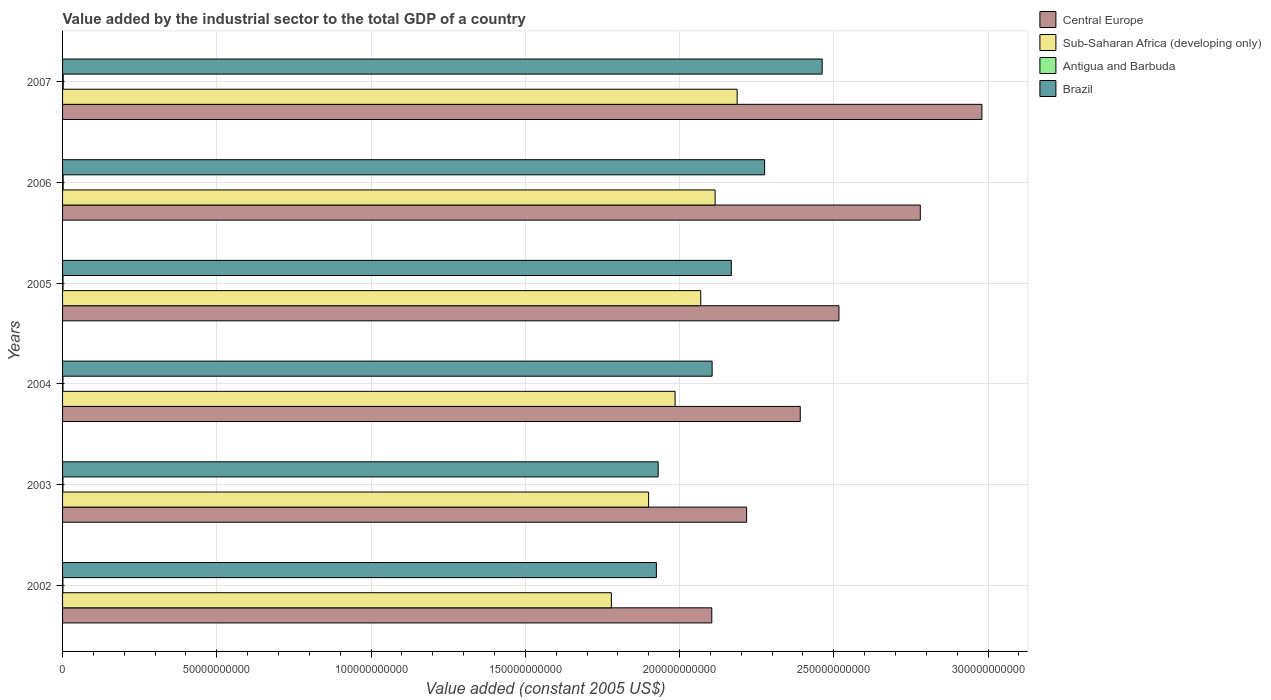How many different coloured bars are there?
Ensure brevity in your answer.  4. How many bars are there on the 5th tick from the bottom?
Keep it short and to the point. 4. What is the label of the 3rd group of bars from the top?
Keep it short and to the point. 2005. What is the value added by the industrial sector in Antigua and Barbuda in 2005?
Ensure brevity in your answer.  1.49e+08. Across all years, what is the maximum value added by the industrial sector in Brazil?
Your answer should be compact. 2.46e+11. Across all years, what is the minimum value added by the industrial sector in Sub-Saharan Africa (developing only)?
Your answer should be very brief. 1.78e+11. In which year was the value added by the industrial sector in Brazil minimum?
Make the answer very short. 2002. What is the total value added by the industrial sector in Antigua and Barbuda in the graph?
Offer a very short reply. 9.26e+08. What is the difference between the value added by the industrial sector in Central Europe in 2003 and that in 2006?
Your answer should be compact. -5.63e+1. What is the difference between the value added by the industrial sector in Brazil in 2006 and the value added by the industrial sector in Antigua and Barbuda in 2003?
Your answer should be compact. 2.27e+11. What is the average value added by the industrial sector in Sub-Saharan Africa (developing only) per year?
Provide a succinct answer. 2.01e+11. In the year 2004, what is the difference between the value added by the industrial sector in Brazil and value added by the industrial sector in Antigua and Barbuda?
Ensure brevity in your answer.  2.10e+11. In how many years, is the value added by the industrial sector in Antigua and Barbuda greater than 10000000000 US$?
Your answer should be very brief. 0. What is the ratio of the value added by the industrial sector in Sub-Saharan Africa (developing only) in 2002 to that in 2005?
Your response must be concise. 0.86. Is the value added by the industrial sector in Sub-Saharan Africa (developing only) in 2003 less than that in 2007?
Ensure brevity in your answer.  Yes. What is the difference between the highest and the second highest value added by the industrial sector in Brazil?
Keep it short and to the point. 1.87e+1. What is the difference between the highest and the lowest value added by the industrial sector in Central Europe?
Give a very brief answer. 8.76e+1. Is it the case that in every year, the sum of the value added by the industrial sector in Antigua and Barbuda and value added by the industrial sector in Sub-Saharan Africa (developing only) is greater than the sum of value added by the industrial sector in Central Europe and value added by the industrial sector in Brazil?
Provide a short and direct response. Yes. What does the 3rd bar from the top in 2006 represents?
Ensure brevity in your answer.  Sub-Saharan Africa (developing only). What does the 2nd bar from the bottom in 2006 represents?
Ensure brevity in your answer.  Sub-Saharan Africa (developing only). Is it the case that in every year, the sum of the value added by the industrial sector in Antigua and Barbuda and value added by the industrial sector in Sub-Saharan Africa (developing only) is greater than the value added by the industrial sector in Brazil?
Your answer should be very brief. No. Are all the bars in the graph horizontal?
Keep it short and to the point. Yes. Are the values on the major ticks of X-axis written in scientific E-notation?
Make the answer very short. No. Where does the legend appear in the graph?
Make the answer very short. Top right. How many legend labels are there?
Your answer should be very brief. 4. How are the legend labels stacked?
Offer a very short reply. Vertical. What is the title of the graph?
Offer a very short reply. Value added by the industrial sector to the total GDP of a country. Does "Lower middle income" appear as one of the legend labels in the graph?
Ensure brevity in your answer.  No. What is the label or title of the X-axis?
Keep it short and to the point. Value added (constant 2005 US$). What is the label or title of the Y-axis?
Make the answer very short. Years. What is the Value added (constant 2005 US$) of Central Europe in 2002?
Keep it short and to the point. 2.10e+11. What is the Value added (constant 2005 US$) in Sub-Saharan Africa (developing only) in 2002?
Provide a succinct answer. 1.78e+11. What is the Value added (constant 2005 US$) of Antigua and Barbuda in 2002?
Keep it short and to the point. 1.12e+08. What is the Value added (constant 2005 US$) in Brazil in 2002?
Provide a succinct answer. 1.92e+11. What is the Value added (constant 2005 US$) of Central Europe in 2003?
Keep it short and to the point. 2.22e+11. What is the Value added (constant 2005 US$) in Sub-Saharan Africa (developing only) in 2003?
Your response must be concise. 1.90e+11. What is the Value added (constant 2005 US$) in Antigua and Barbuda in 2003?
Make the answer very short. 1.22e+08. What is the Value added (constant 2005 US$) of Brazil in 2003?
Keep it short and to the point. 1.93e+11. What is the Value added (constant 2005 US$) of Central Europe in 2004?
Your response must be concise. 2.39e+11. What is the Value added (constant 2005 US$) in Sub-Saharan Africa (developing only) in 2004?
Offer a very short reply. 1.99e+11. What is the Value added (constant 2005 US$) of Antigua and Barbuda in 2004?
Your answer should be compact. 1.24e+08. What is the Value added (constant 2005 US$) of Brazil in 2004?
Your response must be concise. 2.11e+11. What is the Value added (constant 2005 US$) of Central Europe in 2005?
Ensure brevity in your answer.  2.52e+11. What is the Value added (constant 2005 US$) in Sub-Saharan Africa (developing only) in 2005?
Keep it short and to the point. 2.07e+11. What is the Value added (constant 2005 US$) of Antigua and Barbuda in 2005?
Make the answer very short. 1.49e+08. What is the Value added (constant 2005 US$) in Brazil in 2005?
Make the answer very short. 2.17e+11. What is the Value added (constant 2005 US$) in Central Europe in 2006?
Your response must be concise. 2.78e+11. What is the Value added (constant 2005 US$) in Sub-Saharan Africa (developing only) in 2006?
Make the answer very short. 2.12e+11. What is the Value added (constant 2005 US$) of Antigua and Barbuda in 2006?
Offer a terse response. 2.01e+08. What is the Value added (constant 2005 US$) in Brazil in 2006?
Ensure brevity in your answer.  2.28e+11. What is the Value added (constant 2005 US$) of Central Europe in 2007?
Keep it short and to the point. 2.98e+11. What is the Value added (constant 2005 US$) in Sub-Saharan Africa (developing only) in 2007?
Offer a very short reply. 2.19e+11. What is the Value added (constant 2005 US$) of Antigua and Barbuda in 2007?
Your answer should be very brief. 2.17e+08. What is the Value added (constant 2005 US$) in Brazil in 2007?
Offer a very short reply. 2.46e+11. Across all years, what is the maximum Value added (constant 2005 US$) in Central Europe?
Ensure brevity in your answer.  2.98e+11. Across all years, what is the maximum Value added (constant 2005 US$) in Sub-Saharan Africa (developing only)?
Your answer should be very brief. 2.19e+11. Across all years, what is the maximum Value added (constant 2005 US$) in Antigua and Barbuda?
Offer a very short reply. 2.17e+08. Across all years, what is the maximum Value added (constant 2005 US$) of Brazil?
Ensure brevity in your answer.  2.46e+11. Across all years, what is the minimum Value added (constant 2005 US$) in Central Europe?
Provide a succinct answer. 2.10e+11. Across all years, what is the minimum Value added (constant 2005 US$) in Sub-Saharan Africa (developing only)?
Make the answer very short. 1.78e+11. Across all years, what is the minimum Value added (constant 2005 US$) in Antigua and Barbuda?
Make the answer very short. 1.12e+08. Across all years, what is the minimum Value added (constant 2005 US$) in Brazil?
Give a very brief answer. 1.92e+11. What is the total Value added (constant 2005 US$) in Central Europe in the graph?
Offer a terse response. 1.50e+12. What is the total Value added (constant 2005 US$) in Sub-Saharan Africa (developing only) in the graph?
Your answer should be very brief. 1.20e+12. What is the total Value added (constant 2005 US$) of Antigua and Barbuda in the graph?
Offer a terse response. 9.26e+08. What is the total Value added (constant 2005 US$) of Brazil in the graph?
Offer a very short reply. 1.29e+12. What is the difference between the Value added (constant 2005 US$) of Central Europe in 2002 and that in 2003?
Keep it short and to the point. -1.13e+1. What is the difference between the Value added (constant 2005 US$) in Sub-Saharan Africa (developing only) in 2002 and that in 2003?
Give a very brief answer. -1.21e+1. What is the difference between the Value added (constant 2005 US$) in Antigua and Barbuda in 2002 and that in 2003?
Make the answer very short. -9.71e+06. What is the difference between the Value added (constant 2005 US$) in Brazil in 2002 and that in 2003?
Your answer should be very brief. -5.84e+08. What is the difference between the Value added (constant 2005 US$) of Central Europe in 2002 and that in 2004?
Offer a terse response. -2.87e+1. What is the difference between the Value added (constant 2005 US$) of Sub-Saharan Africa (developing only) in 2002 and that in 2004?
Give a very brief answer. -2.07e+1. What is the difference between the Value added (constant 2005 US$) of Antigua and Barbuda in 2002 and that in 2004?
Ensure brevity in your answer.  -1.19e+07. What is the difference between the Value added (constant 2005 US$) of Brazil in 2002 and that in 2004?
Offer a terse response. -1.81e+1. What is the difference between the Value added (constant 2005 US$) in Central Europe in 2002 and that in 2005?
Make the answer very short. -4.12e+1. What is the difference between the Value added (constant 2005 US$) of Sub-Saharan Africa (developing only) in 2002 and that in 2005?
Provide a short and direct response. -2.90e+1. What is the difference between the Value added (constant 2005 US$) in Antigua and Barbuda in 2002 and that in 2005?
Provide a succinct answer. -3.62e+07. What is the difference between the Value added (constant 2005 US$) in Brazil in 2002 and that in 2005?
Ensure brevity in your answer.  -2.43e+1. What is the difference between the Value added (constant 2005 US$) in Central Europe in 2002 and that in 2006?
Offer a very short reply. -6.76e+1. What is the difference between the Value added (constant 2005 US$) of Sub-Saharan Africa (developing only) in 2002 and that in 2006?
Offer a terse response. -3.36e+1. What is the difference between the Value added (constant 2005 US$) in Antigua and Barbuda in 2002 and that in 2006?
Your answer should be compact. -8.89e+07. What is the difference between the Value added (constant 2005 US$) in Brazil in 2002 and that in 2006?
Offer a terse response. -3.51e+1. What is the difference between the Value added (constant 2005 US$) in Central Europe in 2002 and that in 2007?
Make the answer very short. -8.76e+1. What is the difference between the Value added (constant 2005 US$) in Sub-Saharan Africa (developing only) in 2002 and that in 2007?
Provide a succinct answer. -4.08e+1. What is the difference between the Value added (constant 2005 US$) in Antigua and Barbuda in 2002 and that in 2007?
Provide a short and direct response. -1.05e+08. What is the difference between the Value added (constant 2005 US$) in Brazil in 2002 and that in 2007?
Make the answer very short. -5.37e+1. What is the difference between the Value added (constant 2005 US$) of Central Europe in 2003 and that in 2004?
Offer a terse response. -1.74e+1. What is the difference between the Value added (constant 2005 US$) of Sub-Saharan Africa (developing only) in 2003 and that in 2004?
Your response must be concise. -8.58e+09. What is the difference between the Value added (constant 2005 US$) in Antigua and Barbuda in 2003 and that in 2004?
Your answer should be compact. -2.22e+06. What is the difference between the Value added (constant 2005 US$) in Brazil in 2003 and that in 2004?
Provide a succinct answer. -1.75e+1. What is the difference between the Value added (constant 2005 US$) in Central Europe in 2003 and that in 2005?
Make the answer very short. -2.99e+1. What is the difference between the Value added (constant 2005 US$) of Sub-Saharan Africa (developing only) in 2003 and that in 2005?
Your answer should be compact. -1.69e+1. What is the difference between the Value added (constant 2005 US$) of Antigua and Barbuda in 2003 and that in 2005?
Provide a succinct answer. -2.65e+07. What is the difference between the Value added (constant 2005 US$) in Brazil in 2003 and that in 2005?
Your answer should be compact. -2.37e+1. What is the difference between the Value added (constant 2005 US$) of Central Europe in 2003 and that in 2006?
Your response must be concise. -5.63e+1. What is the difference between the Value added (constant 2005 US$) of Sub-Saharan Africa (developing only) in 2003 and that in 2006?
Provide a short and direct response. -2.16e+1. What is the difference between the Value added (constant 2005 US$) of Antigua and Barbuda in 2003 and that in 2006?
Give a very brief answer. -7.92e+07. What is the difference between the Value added (constant 2005 US$) of Brazil in 2003 and that in 2006?
Your response must be concise. -3.45e+1. What is the difference between the Value added (constant 2005 US$) of Central Europe in 2003 and that in 2007?
Keep it short and to the point. -7.63e+1. What is the difference between the Value added (constant 2005 US$) in Sub-Saharan Africa (developing only) in 2003 and that in 2007?
Offer a terse response. -2.87e+1. What is the difference between the Value added (constant 2005 US$) of Antigua and Barbuda in 2003 and that in 2007?
Provide a short and direct response. -9.55e+07. What is the difference between the Value added (constant 2005 US$) in Brazil in 2003 and that in 2007?
Ensure brevity in your answer.  -5.32e+1. What is the difference between the Value added (constant 2005 US$) in Central Europe in 2004 and that in 2005?
Your answer should be very brief. -1.25e+1. What is the difference between the Value added (constant 2005 US$) in Sub-Saharan Africa (developing only) in 2004 and that in 2005?
Offer a very short reply. -8.32e+09. What is the difference between the Value added (constant 2005 US$) in Antigua and Barbuda in 2004 and that in 2005?
Ensure brevity in your answer.  -2.43e+07. What is the difference between the Value added (constant 2005 US$) of Brazil in 2004 and that in 2005?
Make the answer very short. -6.22e+09. What is the difference between the Value added (constant 2005 US$) in Central Europe in 2004 and that in 2006?
Your answer should be very brief. -3.89e+1. What is the difference between the Value added (constant 2005 US$) in Sub-Saharan Africa (developing only) in 2004 and that in 2006?
Offer a very short reply. -1.30e+1. What is the difference between the Value added (constant 2005 US$) of Antigua and Barbuda in 2004 and that in 2006?
Give a very brief answer. -7.69e+07. What is the difference between the Value added (constant 2005 US$) of Brazil in 2004 and that in 2006?
Offer a terse response. -1.70e+1. What is the difference between the Value added (constant 2005 US$) of Central Europe in 2004 and that in 2007?
Ensure brevity in your answer.  -5.89e+1. What is the difference between the Value added (constant 2005 US$) of Sub-Saharan Africa (developing only) in 2004 and that in 2007?
Keep it short and to the point. -2.01e+1. What is the difference between the Value added (constant 2005 US$) in Antigua and Barbuda in 2004 and that in 2007?
Provide a short and direct response. -9.32e+07. What is the difference between the Value added (constant 2005 US$) in Brazil in 2004 and that in 2007?
Offer a terse response. -3.57e+1. What is the difference between the Value added (constant 2005 US$) in Central Europe in 2005 and that in 2006?
Ensure brevity in your answer.  -2.64e+1. What is the difference between the Value added (constant 2005 US$) of Sub-Saharan Africa (developing only) in 2005 and that in 2006?
Your answer should be compact. -4.66e+09. What is the difference between the Value added (constant 2005 US$) in Antigua and Barbuda in 2005 and that in 2006?
Make the answer very short. -5.26e+07. What is the difference between the Value added (constant 2005 US$) of Brazil in 2005 and that in 2006?
Your response must be concise. -1.08e+1. What is the difference between the Value added (constant 2005 US$) of Central Europe in 2005 and that in 2007?
Ensure brevity in your answer.  -4.63e+1. What is the difference between the Value added (constant 2005 US$) of Sub-Saharan Africa (developing only) in 2005 and that in 2007?
Provide a succinct answer. -1.18e+1. What is the difference between the Value added (constant 2005 US$) of Antigua and Barbuda in 2005 and that in 2007?
Give a very brief answer. -6.89e+07. What is the difference between the Value added (constant 2005 US$) of Brazil in 2005 and that in 2007?
Make the answer very short. -2.95e+1. What is the difference between the Value added (constant 2005 US$) in Central Europe in 2006 and that in 2007?
Give a very brief answer. -2.00e+1. What is the difference between the Value added (constant 2005 US$) of Sub-Saharan Africa (developing only) in 2006 and that in 2007?
Give a very brief answer. -7.14e+09. What is the difference between the Value added (constant 2005 US$) of Antigua and Barbuda in 2006 and that in 2007?
Your answer should be compact. -1.63e+07. What is the difference between the Value added (constant 2005 US$) in Brazil in 2006 and that in 2007?
Ensure brevity in your answer.  -1.87e+1. What is the difference between the Value added (constant 2005 US$) of Central Europe in 2002 and the Value added (constant 2005 US$) of Sub-Saharan Africa (developing only) in 2003?
Ensure brevity in your answer.  2.05e+1. What is the difference between the Value added (constant 2005 US$) in Central Europe in 2002 and the Value added (constant 2005 US$) in Antigua and Barbuda in 2003?
Offer a terse response. 2.10e+11. What is the difference between the Value added (constant 2005 US$) in Central Europe in 2002 and the Value added (constant 2005 US$) in Brazil in 2003?
Provide a succinct answer. 1.74e+1. What is the difference between the Value added (constant 2005 US$) in Sub-Saharan Africa (developing only) in 2002 and the Value added (constant 2005 US$) in Antigua and Barbuda in 2003?
Keep it short and to the point. 1.78e+11. What is the difference between the Value added (constant 2005 US$) in Sub-Saharan Africa (developing only) in 2002 and the Value added (constant 2005 US$) in Brazil in 2003?
Provide a short and direct response. -1.52e+1. What is the difference between the Value added (constant 2005 US$) in Antigua and Barbuda in 2002 and the Value added (constant 2005 US$) in Brazil in 2003?
Provide a short and direct response. -1.93e+11. What is the difference between the Value added (constant 2005 US$) of Central Europe in 2002 and the Value added (constant 2005 US$) of Sub-Saharan Africa (developing only) in 2004?
Provide a short and direct response. 1.19e+1. What is the difference between the Value added (constant 2005 US$) in Central Europe in 2002 and the Value added (constant 2005 US$) in Antigua and Barbuda in 2004?
Your answer should be compact. 2.10e+11. What is the difference between the Value added (constant 2005 US$) of Central Europe in 2002 and the Value added (constant 2005 US$) of Brazil in 2004?
Your answer should be very brief. -1.05e+08. What is the difference between the Value added (constant 2005 US$) in Sub-Saharan Africa (developing only) in 2002 and the Value added (constant 2005 US$) in Antigua and Barbuda in 2004?
Offer a terse response. 1.78e+11. What is the difference between the Value added (constant 2005 US$) of Sub-Saharan Africa (developing only) in 2002 and the Value added (constant 2005 US$) of Brazil in 2004?
Give a very brief answer. -3.27e+1. What is the difference between the Value added (constant 2005 US$) of Antigua and Barbuda in 2002 and the Value added (constant 2005 US$) of Brazil in 2004?
Provide a succinct answer. -2.10e+11. What is the difference between the Value added (constant 2005 US$) in Central Europe in 2002 and the Value added (constant 2005 US$) in Sub-Saharan Africa (developing only) in 2005?
Your answer should be compact. 3.58e+09. What is the difference between the Value added (constant 2005 US$) of Central Europe in 2002 and the Value added (constant 2005 US$) of Antigua and Barbuda in 2005?
Offer a terse response. 2.10e+11. What is the difference between the Value added (constant 2005 US$) of Central Europe in 2002 and the Value added (constant 2005 US$) of Brazil in 2005?
Offer a very short reply. -6.33e+09. What is the difference between the Value added (constant 2005 US$) of Sub-Saharan Africa (developing only) in 2002 and the Value added (constant 2005 US$) of Antigua and Barbuda in 2005?
Keep it short and to the point. 1.78e+11. What is the difference between the Value added (constant 2005 US$) of Sub-Saharan Africa (developing only) in 2002 and the Value added (constant 2005 US$) of Brazil in 2005?
Provide a short and direct response. -3.89e+1. What is the difference between the Value added (constant 2005 US$) in Antigua and Barbuda in 2002 and the Value added (constant 2005 US$) in Brazil in 2005?
Your answer should be compact. -2.17e+11. What is the difference between the Value added (constant 2005 US$) in Central Europe in 2002 and the Value added (constant 2005 US$) in Sub-Saharan Africa (developing only) in 2006?
Make the answer very short. -1.07e+09. What is the difference between the Value added (constant 2005 US$) in Central Europe in 2002 and the Value added (constant 2005 US$) in Antigua and Barbuda in 2006?
Provide a succinct answer. 2.10e+11. What is the difference between the Value added (constant 2005 US$) of Central Europe in 2002 and the Value added (constant 2005 US$) of Brazil in 2006?
Offer a very short reply. -1.71e+1. What is the difference between the Value added (constant 2005 US$) in Sub-Saharan Africa (developing only) in 2002 and the Value added (constant 2005 US$) in Antigua and Barbuda in 2006?
Offer a terse response. 1.78e+11. What is the difference between the Value added (constant 2005 US$) in Sub-Saharan Africa (developing only) in 2002 and the Value added (constant 2005 US$) in Brazil in 2006?
Your answer should be very brief. -4.97e+1. What is the difference between the Value added (constant 2005 US$) of Antigua and Barbuda in 2002 and the Value added (constant 2005 US$) of Brazil in 2006?
Provide a short and direct response. -2.27e+11. What is the difference between the Value added (constant 2005 US$) in Central Europe in 2002 and the Value added (constant 2005 US$) in Sub-Saharan Africa (developing only) in 2007?
Make the answer very short. -8.21e+09. What is the difference between the Value added (constant 2005 US$) of Central Europe in 2002 and the Value added (constant 2005 US$) of Antigua and Barbuda in 2007?
Your answer should be very brief. 2.10e+11. What is the difference between the Value added (constant 2005 US$) in Central Europe in 2002 and the Value added (constant 2005 US$) in Brazil in 2007?
Offer a very short reply. -3.58e+1. What is the difference between the Value added (constant 2005 US$) of Sub-Saharan Africa (developing only) in 2002 and the Value added (constant 2005 US$) of Antigua and Barbuda in 2007?
Offer a very short reply. 1.78e+11. What is the difference between the Value added (constant 2005 US$) in Sub-Saharan Africa (developing only) in 2002 and the Value added (constant 2005 US$) in Brazil in 2007?
Provide a succinct answer. -6.83e+1. What is the difference between the Value added (constant 2005 US$) in Antigua and Barbuda in 2002 and the Value added (constant 2005 US$) in Brazil in 2007?
Your response must be concise. -2.46e+11. What is the difference between the Value added (constant 2005 US$) of Central Europe in 2003 and the Value added (constant 2005 US$) of Sub-Saharan Africa (developing only) in 2004?
Your response must be concise. 2.32e+1. What is the difference between the Value added (constant 2005 US$) of Central Europe in 2003 and the Value added (constant 2005 US$) of Antigua and Barbuda in 2004?
Offer a very short reply. 2.22e+11. What is the difference between the Value added (constant 2005 US$) in Central Europe in 2003 and the Value added (constant 2005 US$) in Brazil in 2004?
Your response must be concise. 1.12e+1. What is the difference between the Value added (constant 2005 US$) in Sub-Saharan Africa (developing only) in 2003 and the Value added (constant 2005 US$) in Antigua and Barbuda in 2004?
Ensure brevity in your answer.  1.90e+11. What is the difference between the Value added (constant 2005 US$) in Sub-Saharan Africa (developing only) in 2003 and the Value added (constant 2005 US$) in Brazil in 2004?
Give a very brief answer. -2.06e+1. What is the difference between the Value added (constant 2005 US$) in Antigua and Barbuda in 2003 and the Value added (constant 2005 US$) in Brazil in 2004?
Your answer should be compact. -2.10e+11. What is the difference between the Value added (constant 2005 US$) in Central Europe in 2003 and the Value added (constant 2005 US$) in Sub-Saharan Africa (developing only) in 2005?
Your answer should be very brief. 1.49e+1. What is the difference between the Value added (constant 2005 US$) of Central Europe in 2003 and the Value added (constant 2005 US$) of Antigua and Barbuda in 2005?
Offer a very short reply. 2.22e+11. What is the difference between the Value added (constant 2005 US$) of Central Europe in 2003 and the Value added (constant 2005 US$) of Brazil in 2005?
Provide a short and direct response. 4.96e+09. What is the difference between the Value added (constant 2005 US$) in Sub-Saharan Africa (developing only) in 2003 and the Value added (constant 2005 US$) in Antigua and Barbuda in 2005?
Give a very brief answer. 1.90e+11. What is the difference between the Value added (constant 2005 US$) in Sub-Saharan Africa (developing only) in 2003 and the Value added (constant 2005 US$) in Brazil in 2005?
Give a very brief answer. -2.68e+1. What is the difference between the Value added (constant 2005 US$) in Antigua and Barbuda in 2003 and the Value added (constant 2005 US$) in Brazil in 2005?
Your response must be concise. -2.17e+11. What is the difference between the Value added (constant 2005 US$) of Central Europe in 2003 and the Value added (constant 2005 US$) of Sub-Saharan Africa (developing only) in 2006?
Keep it short and to the point. 1.02e+1. What is the difference between the Value added (constant 2005 US$) in Central Europe in 2003 and the Value added (constant 2005 US$) in Antigua and Barbuda in 2006?
Offer a terse response. 2.22e+11. What is the difference between the Value added (constant 2005 US$) in Central Europe in 2003 and the Value added (constant 2005 US$) in Brazil in 2006?
Provide a short and direct response. -5.83e+09. What is the difference between the Value added (constant 2005 US$) of Sub-Saharan Africa (developing only) in 2003 and the Value added (constant 2005 US$) of Antigua and Barbuda in 2006?
Your answer should be compact. 1.90e+11. What is the difference between the Value added (constant 2005 US$) in Sub-Saharan Africa (developing only) in 2003 and the Value added (constant 2005 US$) in Brazil in 2006?
Your answer should be compact. -3.76e+1. What is the difference between the Value added (constant 2005 US$) in Antigua and Barbuda in 2003 and the Value added (constant 2005 US$) in Brazil in 2006?
Ensure brevity in your answer.  -2.27e+11. What is the difference between the Value added (constant 2005 US$) in Central Europe in 2003 and the Value added (constant 2005 US$) in Sub-Saharan Africa (developing only) in 2007?
Give a very brief answer. 3.07e+09. What is the difference between the Value added (constant 2005 US$) in Central Europe in 2003 and the Value added (constant 2005 US$) in Antigua and Barbuda in 2007?
Ensure brevity in your answer.  2.22e+11. What is the difference between the Value added (constant 2005 US$) in Central Europe in 2003 and the Value added (constant 2005 US$) in Brazil in 2007?
Your answer should be very brief. -2.45e+1. What is the difference between the Value added (constant 2005 US$) of Sub-Saharan Africa (developing only) in 2003 and the Value added (constant 2005 US$) of Antigua and Barbuda in 2007?
Keep it short and to the point. 1.90e+11. What is the difference between the Value added (constant 2005 US$) of Sub-Saharan Africa (developing only) in 2003 and the Value added (constant 2005 US$) of Brazil in 2007?
Provide a short and direct response. -5.63e+1. What is the difference between the Value added (constant 2005 US$) in Antigua and Barbuda in 2003 and the Value added (constant 2005 US$) in Brazil in 2007?
Provide a succinct answer. -2.46e+11. What is the difference between the Value added (constant 2005 US$) in Central Europe in 2004 and the Value added (constant 2005 US$) in Sub-Saharan Africa (developing only) in 2005?
Make the answer very short. 3.23e+1. What is the difference between the Value added (constant 2005 US$) in Central Europe in 2004 and the Value added (constant 2005 US$) in Antigua and Barbuda in 2005?
Your response must be concise. 2.39e+11. What is the difference between the Value added (constant 2005 US$) of Central Europe in 2004 and the Value added (constant 2005 US$) of Brazil in 2005?
Give a very brief answer. 2.23e+1. What is the difference between the Value added (constant 2005 US$) in Sub-Saharan Africa (developing only) in 2004 and the Value added (constant 2005 US$) in Antigua and Barbuda in 2005?
Offer a very short reply. 1.98e+11. What is the difference between the Value added (constant 2005 US$) of Sub-Saharan Africa (developing only) in 2004 and the Value added (constant 2005 US$) of Brazil in 2005?
Provide a succinct answer. -1.82e+1. What is the difference between the Value added (constant 2005 US$) in Antigua and Barbuda in 2004 and the Value added (constant 2005 US$) in Brazil in 2005?
Ensure brevity in your answer.  -2.17e+11. What is the difference between the Value added (constant 2005 US$) of Central Europe in 2004 and the Value added (constant 2005 US$) of Sub-Saharan Africa (developing only) in 2006?
Your answer should be compact. 2.76e+1. What is the difference between the Value added (constant 2005 US$) of Central Europe in 2004 and the Value added (constant 2005 US$) of Antigua and Barbuda in 2006?
Offer a terse response. 2.39e+11. What is the difference between the Value added (constant 2005 US$) in Central Europe in 2004 and the Value added (constant 2005 US$) in Brazil in 2006?
Offer a very short reply. 1.16e+1. What is the difference between the Value added (constant 2005 US$) in Sub-Saharan Africa (developing only) in 2004 and the Value added (constant 2005 US$) in Antigua and Barbuda in 2006?
Give a very brief answer. 1.98e+11. What is the difference between the Value added (constant 2005 US$) of Sub-Saharan Africa (developing only) in 2004 and the Value added (constant 2005 US$) of Brazil in 2006?
Your answer should be very brief. -2.90e+1. What is the difference between the Value added (constant 2005 US$) in Antigua and Barbuda in 2004 and the Value added (constant 2005 US$) in Brazil in 2006?
Your answer should be very brief. -2.27e+11. What is the difference between the Value added (constant 2005 US$) in Central Europe in 2004 and the Value added (constant 2005 US$) in Sub-Saharan Africa (developing only) in 2007?
Offer a very short reply. 2.05e+1. What is the difference between the Value added (constant 2005 US$) of Central Europe in 2004 and the Value added (constant 2005 US$) of Antigua and Barbuda in 2007?
Provide a short and direct response. 2.39e+11. What is the difference between the Value added (constant 2005 US$) of Central Europe in 2004 and the Value added (constant 2005 US$) of Brazil in 2007?
Offer a very short reply. -7.11e+09. What is the difference between the Value added (constant 2005 US$) of Sub-Saharan Africa (developing only) in 2004 and the Value added (constant 2005 US$) of Antigua and Barbuda in 2007?
Give a very brief answer. 1.98e+11. What is the difference between the Value added (constant 2005 US$) in Sub-Saharan Africa (developing only) in 2004 and the Value added (constant 2005 US$) in Brazil in 2007?
Make the answer very short. -4.77e+1. What is the difference between the Value added (constant 2005 US$) in Antigua and Barbuda in 2004 and the Value added (constant 2005 US$) in Brazil in 2007?
Your answer should be very brief. -2.46e+11. What is the difference between the Value added (constant 2005 US$) of Central Europe in 2005 and the Value added (constant 2005 US$) of Sub-Saharan Africa (developing only) in 2006?
Ensure brevity in your answer.  4.01e+1. What is the difference between the Value added (constant 2005 US$) in Central Europe in 2005 and the Value added (constant 2005 US$) in Antigua and Barbuda in 2006?
Provide a succinct answer. 2.51e+11. What is the difference between the Value added (constant 2005 US$) of Central Europe in 2005 and the Value added (constant 2005 US$) of Brazil in 2006?
Offer a very short reply. 2.41e+1. What is the difference between the Value added (constant 2005 US$) of Sub-Saharan Africa (developing only) in 2005 and the Value added (constant 2005 US$) of Antigua and Barbuda in 2006?
Keep it short and to the point. 2.07e+11. What is the difference between the Value added (constant 2005 US$) in Sub-Saharan Africa (developing only) in 2005 and the Value added (constant 2005 US$) in Brazil in 2006?
Ensure brevity in your answer.  -2.07e+1. What is the difference between the Value added (constant 2005 US$) in Antigua and Barbuda in 2005 and the Value added (constant 2005 US$) in Brazil in 2006?
Offer a terse response. -2.27e+11. What is the difference between the Value added (constant 2005 US$) of Central Europe in 2005 and the Value added (constant 2005 US$) of Sub-Saharan Africa (developing only) in 2007?
Your response must be concise. 3.30e+1. What is the difference between the Value added (constant 2005 US$) in Central Europe in 2005 and the Value added (constant 2005 US$) in Antigua and Barbuda in 2007?
Keep it short and to the point. 2.51e+11. What is the difference between the Value added (constant 2005 US$) in Central Europe in 2005 and the Value added (constant 2005 US$) in Brazil in 2007?
Your response must be concise. 5.44e+09. What is the difference between the Value added (constant 2005 US$) of Sub-Saharan Africa (developing only) in 2005 and the Value added (constant 2005 US$) of Antigua and Barbuda in 2007?
Your answer should be very brief. 2.07e+11. What is the difference between the Value added (constant 2005 US$) of Sub-Saharan Africa (developing only) in 2005 and the Value added (constant 2005 US$) of Brazil in 2007?
Provide a short and direct response. -3.94e+1. What is the difference between the Value added (constant 2005 US$) in Antigua and Barbuda in 2005 and the Value added (constant 2005 US$) in Brazil in 2007?
Offer a terse response. -2.46e+11. What is the difference between the Value added (constant 2005 US$) of Central Europe in 2006 and the Value added (constant 2005 US$) of Sub-Saharan Africa (developing only) in 2007?
Offer a terse response. 5.94e+1. What is the difference between the Value added (constant 2005 US$) of Central Europe in 2006 and the Value added (constant 2005 US$) of Antigua and Barbuda in 2007?
Make the answer very short. 2.78e+11. What is the difference between the Value added (constant 2005 US$) in Central Europe in 2006 and the Value added (constant 2005 US$) in Brazil in 2007?
Make the answer very short. 3.18e+1. What is the difference between the Value added (constant 2005 US$) of Sub-Saharan Africa (developing only) in 2006 and the Value added (constant 2005 US$) of Antigua and Barbuda in 2007?
Offer a terse response. 2.11e+11. What is the difference between the Value added (constant 2005 US$) of Sub-Saharan Africa (developing only) in 2006 and the Value added (constant 2005 US$) of Brazil in 2007?
Offer a very short reply. -3.47e+1. What is the difference between the Value added (constant 2005 US$) of Antigua and Barbuda in 2006 and the Value added (constant 2005 US$) of Brazil in 2007?
Offer a very short reply. -2.46e+11. What is the average Value added (constant 2005 US$) in Central Europe per year?
Offer a terse response. 2.50e+11. What is the average Value added (constant 2005 US$) of Sub-Saharan Africa (developing only) per year?
Your response must be concise. 2.01e+11. What is the average Value added (constant 2005 US$) in Antigua and Barbuda per year?
Provide a short and direct response. 1.54e+08. What is the average Value added (constant 2005 US$) in Brazil per year?
Your response must be concise. 2.14e+11. In the year 2002, what is the difference between the Value added (constant 2005 US$) of Central Europe and Value added (constant 2005 US$) of Sub-Saharan Africa (developing only)?
Ensure brevity in your answer.  3.26e+1. In the year 2002, what is the difference between the Value added (constant 2005 US$) of Central Europe and Value added (constant 2005 US$) of Antigua and Barbuda?
Offer a terse response. 2.10e+11. In the year 2002, what is the difference between the Value added (constant 2005 US$) in Central Europe and Value added (constant 2005 US$) in Brazil?
Your answer should be compact. 1.80e+1. In the year 2002, what is the difference between the Value added (constant 2005 US$) of Sub-Saharan Africa (developing only) and Value added (constant 2005 US$) of Antigua and Barbuda?
Ensure brevity in your answer.  1.78e+11. In the year 2002, what is the difference between the Value added (constant 2005 US$) in Sub-Saharan Africa (developing only) and Value added (constant 2005 US$) in Brazil?
Offer a very short reply. -1.46e+1. In the year 2002, what is the difference between the Value added (constant 2005 US$) of Antigua and Barbuda and Value added (constant 2005 US$) of Brazil?
Keep it short and to the point. -1.92e+11. In the year 2003, what is the difference between the Value added (constant 2005 US$) of Central Europe and Value added (constant 2005 US$) of Sub-Saharan Africa (developing only)?
Your answer should be very brief. 3.18e+1. In the year 2003, what is the difference between the Value added (constant 2005 US$) in Central Europe and Value added (constant 2005 US$) in Antigua and Barbuda?
Your response must be concise. 2.22e+11. In the year 2003, what is the difference between the Value added (constant 2005 US$) of Central Europe and Value added (constant 2005 US$) of Brazil?
Make the answer very short. 2.87e+1. In the year 2003, what is the difference between the Value added (constant 2005 US$) in Sub-Saharan Africa (developing only) and Value added (constant 2005 US$) in Antigua and Barbuda?
Your response must be concise. 1.90e+11. In the year 2003, what is the difference between the Value added (constant 2005 US$) in Sub-Saharan Africa (developing only) and Value added (constant 2005 US$) in Brazil?
Ensure brevity in your answer.  -3.10e+09. In the year 2003, what is the difference between the Value added (constant 2005 US$) in Antigua and Barbuda and Value added (constant 2005 US$) in Brazil?
Provide a short and direct response. -1.93e+11. In the year 2004, what is the difference between the Value added (constant 2005 US$) in Central Europe and Value added (constant 2005 US$) in Sub-Saharan Africa (developing only)?
Make the answer very short. 4.06e+1. In the year 2004, what is the difference between the Value added (constant 2005 US$) of Central Europe and Value added (constant 2005 US$) of Antigua and Barbuda?
Make the answer very short. 2.39e+11. In the year 2004, what is the difference between the Value added (constant 2005 US$) of Central Europe and Value added (constant 2005 US$) of Brazil?
Your answer should be very brief. 2.86e+1. In the year 2004, what is the difference between the Value added (constant 2005 US$) in Sub-Saharan Africa (developing only) and Value added (constant 2005 US$) in Antigua and Barbuda?
Your answer should be compact. 1.98e+11. In the year 2004, what is the difference between the Value added (constant 2005 US$) of Sub-Saharan Africa (developing only) and Value added (constant 2005 US$) of Brazil?
Provide a succinct answer. -1.20e+1. In the year 2004, what is the difference between the Value added (constant 2005 US$) of Antigua and Barbuda and Value added (constant 2005 US$) of Brazil?
Keep it short and to the point. -2.10e+11. In the year 2005, what is the difference between the Value added (constant 2005 US$) of Central Europe and Value added (constant 2005 US$) of Sub-Saharan Africa (developing only)?
Make the answer very short. 4.48e+1. In the year 2005, what is the difference between the Value added (constant 2005 US$) of Central Europe and Value added (constant 2005 US$) of Antigua and Barbuda?
Provide a short and direct response. 2.52e+11. In the year 2005, what is the difference between the Value added (constant 2005 US$) in Central Europe and Value added (constant 2005 US$) in Brazil?
Offer a very short reply. 3.49e+1. In the year 2005, what is the difference between the Value added (constant 2005 US$) in Sub-Saharan Africa (developing only) and Value added (constant 2005 US$) in Antigua and Barbuda?
Your answer should be very brief. 2.07e+11. In the year 2005, what is the difference between the Value added (constant 2005 US$) of Sub-Saharan Africa (developing only) and Value added (constant 2005 US$) of Brazil?
Your answer should be very brief. -9.91e+09. In the year 2005, what is the difference between the Value added (constant 2005 US$) in Antigua and Barbuda and Value added (constant 2005 US$) in Brazil?
Keep it short and to the point. -2.17e+11. In the year 2006, what is the difference between the Value added (constant 2005 US$) of Central Europe and Value added (constant 2005 US$) of Sub-Saharan Africa (developing only)?
Make the answer very short. 6.65e+1. In the year 2006, what is the difference between the Value added (constant 2005 US$) in Central Europe and Value added (constant 2005 US$) in Antigua and Barbuda?
Keep it short and to the point. 2.78e+11. In the year 2006, what is the difference between the Value added (constant 2005 US$) in Central Europe and Value added (constant 2005 US$) in Brazil?
Offer a very short reply. 5.05e+1. In the year 2006, what is the difference between the Value added (constant 2005 US$) in Sub-Saharan Africa (developing only) and Value added (constant 2005 US$) in Antigua and Barbuda?
Ensure brevity in your answer.  2.11e+11. In the year 2006, what is the difference between the Value added (constant 2005 US$) in Sub-Saharan Africa (developing only) and Value added (constant 2005 US$) in Brazil?
Provide a succinct answer. -1.60e+1. In the year 2006, what is the difference between the Value added (constant 2005 US$) of Antigua and Barbuda and Value added (constant 2005 US$) of Brazil?
Ensure brevity in your answer.  -2.27e+11. In the year 2007, what is the difference between the Value added (constant 2005 US$) in Central Europe and Value added (constant 2005 US$) in Sub-Saharan Africa (developing only)?
Your answer should be compact. 7.93e+1. In the year 2007, what is the difference between the Value added (constant 2005 US$) of Central Europe and Value added (constant 2005 US$) of Antigua and Barbuda?
Offer a terse response. 2.98e+11. In the year 2007, what is the difference between the Value added (constant 2005 US$) in Central Europe and Value added (constant 2005 US$) in Brazil?
Make the answer very short. 5.18e+1. In the year 2007, what is the difference between the Value added (constant 2005 US$) of Sub-Saharan Africa (developing only) and Value added (constant 2005 US$) of Antigua and Barbuda?
Offer a very short reply. 2.18e+11. In the year 2007, what is the difference between the Value added (constant 2005 US$) in Sub-Saharan Africa (developing only) and Value added (constant 2005 US$) in Brazil?
Offer a very short reply. -2.76e+1. In the year 2007, what is the difference between the Value added (constant 2005 US$) of Antigua and Barbuda and Value added (constant 2005 US$) of Brazil?
Offer a terse response. -2.46e+11. What is the ratio of the Value added (constant 2005 US$) in Central Europe in 2002 to that in 2003?
Your answer should be compact. 0.95. What is the ratio of the Value added (constant 2005 US$) in Sub-Saharan Africa (developing only) in 2002 to that in 2003?
Give a very brief answer. 0.94. What is the ratio of the Value added (constant 2005 US$) of Antigua and Barbuda in 2002 to that in 2003?
Make the answer very short. 0.92. What is the ratio of the Value added (constant 2005 US$) in Brazil in 2002 to that in 2003?
Provide a succinct answer. 1. What is the ratio of the Value added (constant 2005 US$) in Central Europe in 2002 to that in 2004?
Provide a short and direct response. 0.88. What is the ratio of the Value added (constant 2005 US$) in Sub-Saharan Africa (developing only) in 2002 to that in 2004?
Ensure brevity in your answer.  0.9. What is the ratio of the Value added (constant 2005 US$) in Antigua and Barbuda in 2002 to that in 2004?
Provide a succinct answer. 0.9. What is the ratio of the Value added (constant 2005 US$) in Brazil in 2002 to that in 2004?
Provide a short and direct response. 0.91. What is the ratio of the Value added (constant 2005 US$) in Central Europe in 2002 to that in 2005?
Give a very brief answer. 0.84. What is the ratio of the Value added (constant 2005 US$) of Sub-Saharan Africa (developing only) in 2002 to that in 2005?
Ensure brevity in your answer.  0.86. What is the ratio of the Value added (constant 2005 US$) of Antigua and Barbuda in 2002 to that in 2005?
Your answer should be compact. 0.76. What is the ratio of the Value added (constant 2005 US$) of Brazil in 2002 to that in 2005?
Give a very brief answer. 0.89. What is the ratio of the Value added (constant 2005 US$) in Central Europe in 2002 to that in 2006?
Offer a terse response. 0.76. What is the ratio of the Value added (constant 2005 US$) in Sub-Saharan Africa (developing only) in 2002 to that in 2006?
Make the answer very short. 0.84. What is the ratio of the Value added (constant 2005 US$) in Antigua and Barbuda in 2002 to that in 2006?
Make the answer very short. 0.56. What is the ratio of the Value added (constant 2005 US$) in Brazil in 2002 to that in 2006?
Ensure brevity in your answer.  0.85. What is the ratio of the Value added (constant 2005 US$) of Central Europe in 2002 to that in 2007?
Provide a succinct answer. 0.71. What is the ratio of the Value added (constant 2005 US$) in Sub-Saharan Africa (developing only) in 2002 to that in 2007?
Provide a succinct answer. 0.81. What is the ratio of the Value added (constant 2005 US$) of Antigua and Barbuda in 2002 to that in 2007?
Make the answer very short. 0.52. What is the ratio of the Value added (constant 2005 US$) of Brazil in 2002 to that in 2007?
Provide a succinct answer. 0.78. What is the ratio of the Value added (constant 2005 US$) of Central Europe in 2003 to that in 2004?
Provide a succinct answer. 0.93. What is the ratio of the Value added (constant 2005 US$) in Sub-Saharan Africa (developing only) in 2003 to that in 2004?
Keep it short and to the point. 0.96. What is the ratio of the Value added (constant 2005 US$) of Antigua and Barbuda in 2003 to that in 2004?
Offer a very short reply. 0.98. What is the ratio of the Value added (constant 2005 US$) of Brazil in 2003 to that in 2004?
Ensure brevity in your answer.  0.92. What is the ratio of the Value added (constant 2005 US$) of Central Europe in 2003 to that in 2005?
Your answer should be compact. 0.88. What is the ratio of the Value added (constant 2005 US$) in Sub-Saharan Africa (developing only) in 2003 to that in 2005?
Provide a short and direct response. 0.92. What is the ratio of the Value added (constant 2005 US$) of Antigua and Barbuda in 2003 to that in 2005?
Keep it short and to the point. 0.82. What is the ratio of the Value added (constant 2005 US$) in Brazil in 2003 to that in 2005?
Your response must be concise. 0.89. What is the ratio of the Value added (constant 2005 US$) in Central Europe in 2003 to that in 2006?
Offer a very short reply. 0.8. What is the ratio of the Value added (constant 2005 US$) of Sub-Saharan Africa (developing only) in 2003 to that in 2006?
Provide a short and direct response. 0.9. What is the ratio of the Value added (constant 2005 US$) of Antigua and Barbuda in 2003 to that in 2006?
Your response must be concise. 0.61. What is the ratio of the Value added (constant 2005 US$) of Brazil in 2003 to that in 2006?
Provide a succinct answer. 0.85. What is the ratio of the Value added (constant 2005 US$) of Central Europe in 2003 to that in 2007?
Your response must be concise. 0.74. What is the ratio of the Value added (constant 2005 US$) in Sub-Saharan Africa (developing only) in 2003 to that in 2007?
Provide a succinct answer. 0.87. What is the ratio of the Value added (constant 2005 US$) of Antigua and Barbuda in 2003 to that in 2007?
Keep it short and to the point. 0.56. What is the ratio of the Value added (constant 2005 US$) in Brazil in 2003 to that in 2007?
Ensure brevity in your answer.  0.78. What is the ratio of the Value added (constant 2005 US$) in Central Europe in 2004 to that in 2005?
Make the answer very short. 0.95. What is the ratio of the Value added (constant 2005 US$) in Sub-Saharan Africa (developing only) in 2004 to that in 2005?
Give a very brief answer. 0.96. What is the ratio of the Value added (constant 2005 US$) of Antigua and Barbuda in 2004 to that in 2005?
Keep it short and to the point. 0.84. What is the ratio of the Value added (constant 2005 US$) of Brazil in 2004 to that in 2005?
Offer a terse response. 0.97. What is the ratio of the Value added (constant 2005 US$) of Central Europe in 2004 to that in 2006?
Keep it short and to the point. 0.86. What is the ratio of the Value added (constant 2005 US$) of Sub-Saharan Africa (developing only) in 2004 to that in 2006?
Provide a succinct answer. 0.94. What is the ratio of the Value added (constant 2005 US$) in Antigua and Barbuda in 2004 to that in 2006?
Ensure brevity in your answer.  0.62. What is the ratio of the Value added (constant 2005 US$) of Brazil in 2004 to that in 2006?
Provide a short and direct response. 0.93. What is the ratio of the Value added (constant 2005 US$) of Central Europe in 2004 to that in 2007?
Your answer should be compact. 0.8. What is the ratio of the Value added (constant 2005 US$) of Sub-Saharan Africa (developing only) in 2004 to that in 2007?
Your answer should be very brief. 0.91. What is the ratio of the Value added (constant 2005 US$) in Antigua and Barbuda in 2004 to that in 2007?
Provide a short and direct response. 0.57. What is the ratio of the Value added (constant 2005 US$) in Brazil in 2004 to that in 2007?
Give a very brief answer. 0.86. What is the ratio of the Value added (constant 2005 US$) in Central Europe in 2005 to that in 2006?
Give a very brief answer. 0.91. What is the ratio of the Value added (constant 2005 US$) of Antigua and Barbuda in 2005 to that in 2006?
Your response must be concise. 0.74. What is the ratio of the Value added (constant 2005 US$) of Brazil in 2005 to that in 2006?
Provide a short and direct response. 0.95. What is the ratio of the Value added (constant 2005 US$) of Central Europe in 2005 to that in 2007?
Your answer should be compact. 0.84. What is the ratio of the Value added (constant 2005 US$) in Sub-Saharan Africa (developing only) in 2005 to that in 2007?
Make the answer very short. 0.95. What is the ratio of the Value added (constant 2005 US$) in Antigua and Barbuda in 2005 to that in 2007?
Your response must be concise. 0.68. What is the ratio of the Value added (constant 2005 US$) of Brazil in 2005 to that in 2007?
Your response must be concise. 0.88. What is the ratio of the Value added (constant 2005 US$) of Central Europe in 2006 to that in 2007?
Provide a succinct answer. 0.93. What is the ratio of the Value added (constant 2005 US$) in Sub-Saharan Africa (developing only) in 2006 to that in 2007?
Provide a succinct answer. 0.97. What is the ratio of the Value added (constant 2005 US$) in Antigua and Barbuda in 2006 to that in 2007?
Provide a short and direct response. 0.93. What is the ratio of the Value added (constant 2005 US$) of Brazil in 2006 to that in 2007?
Provide a succinct answer. 0.92. What is the difference between the highest and the second highest Value added (constant 2005 US$) in Central Europe?
Your response must be concise. 2.00e+1. What is the difference between the highest and the second highest Value added (constant 2005 US$) in Sub-Saharan Africa (developing only)?
Offer a very short reply. 7.14e+09. What is the difference between the highest and the second highest Value added (constant 2005 US$) in Antigua and Barbuda?
Offer a terse response. 1.63e+07. What is the difference between the highest and the second highest Value added (constant 2005 US$) of Brazil?
Offer a terse response. 1.87e+1. What is the difference between the highest and the lowest Value added (constant 2005 US$) of Central Europe?
Your answer should be very brief. 8.76e+1. What is the difference between the highest and the lowest Value added (constant 2005 US$) in Sub-Saharan Africa (developing only)?
Provide a short and direct response. 4.08e+1. What is the difference between the highest and the lowest Value added (constant 2005 US$) of Antigua and Barbuda?
Your response must be concise. 1.05e+08. What is the difference between the highest and the lowest Value added (constant 2005 US$) of Brazil?
Your answer should be compact. 5.37e+1. 